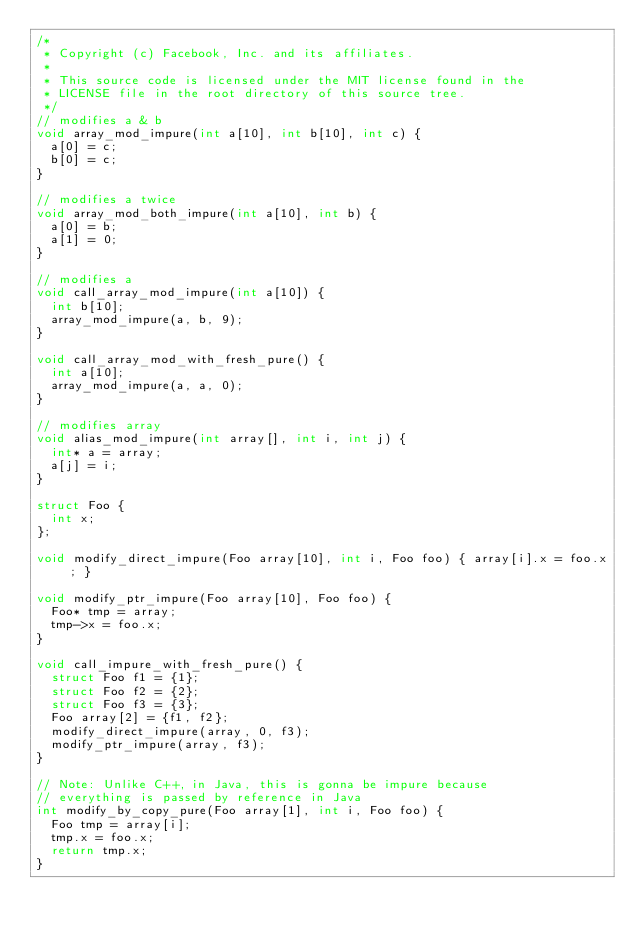Convert code to text. <code><loc_0><loc_0><loc_500><loc_500><_C++_>/*
 * Copyright (c) Facebook, Inc. and its affiliates.
 *
 * This source code is licensed under the MIT license found in the
 * LICENSE file in the root directory of this source tree.
 */
// modifies a & b
void array_mod_impure(int a[10], int b[10], int c) {
  a[0] = c;
  b[0] = c;
}

// modifies a twice
void array_mod_both_impure(int a[10], int b) {
  a[0] = b;
  a[1] = 0;
}

// modifies a
void call_array_mod_impure(int a[10]) {
  int b[10];
  array_mod_impure(a, b, 9);
}

void call_array_mod_with_fresh_pure() {
  int a[10];
  array_mod_impure(a, a, 0);
}

// modifies array
void alias_mod_impure(int array[], int i, int j) {
  int* a = array;
  a[j] = i;
}

struct Foo {
  int x;
};

void modify_direct_impure(Foo array[10], int i, Foo foo) { array[i].x = foo.x; }

void modify_ptr_impure(Foo array[10], Foo foo) {
  Foo* tmp = array;
  tmp->x = foo.x;
}

void call_impure_with_fresh_pure() {
  struct Foo f1 = {1};
  struct Foo f2 = {2};
  struct Foo f3 = {3};
  Foo array[2] = {f1, f2};
  modify_direct_impure(array, 0, f3);
  modify_ptr_impure(array, f3);
}

// Note: Unlike C++, in Java, this is gonna be impure because
// everything is passed by reference in Java
int modify_by_copy_pure(Foo array[1], int i, Foo foo) {
  Foo tmp = array[i];
  tmp.x = foo.x;
  return tmp.x;
}
</code> 